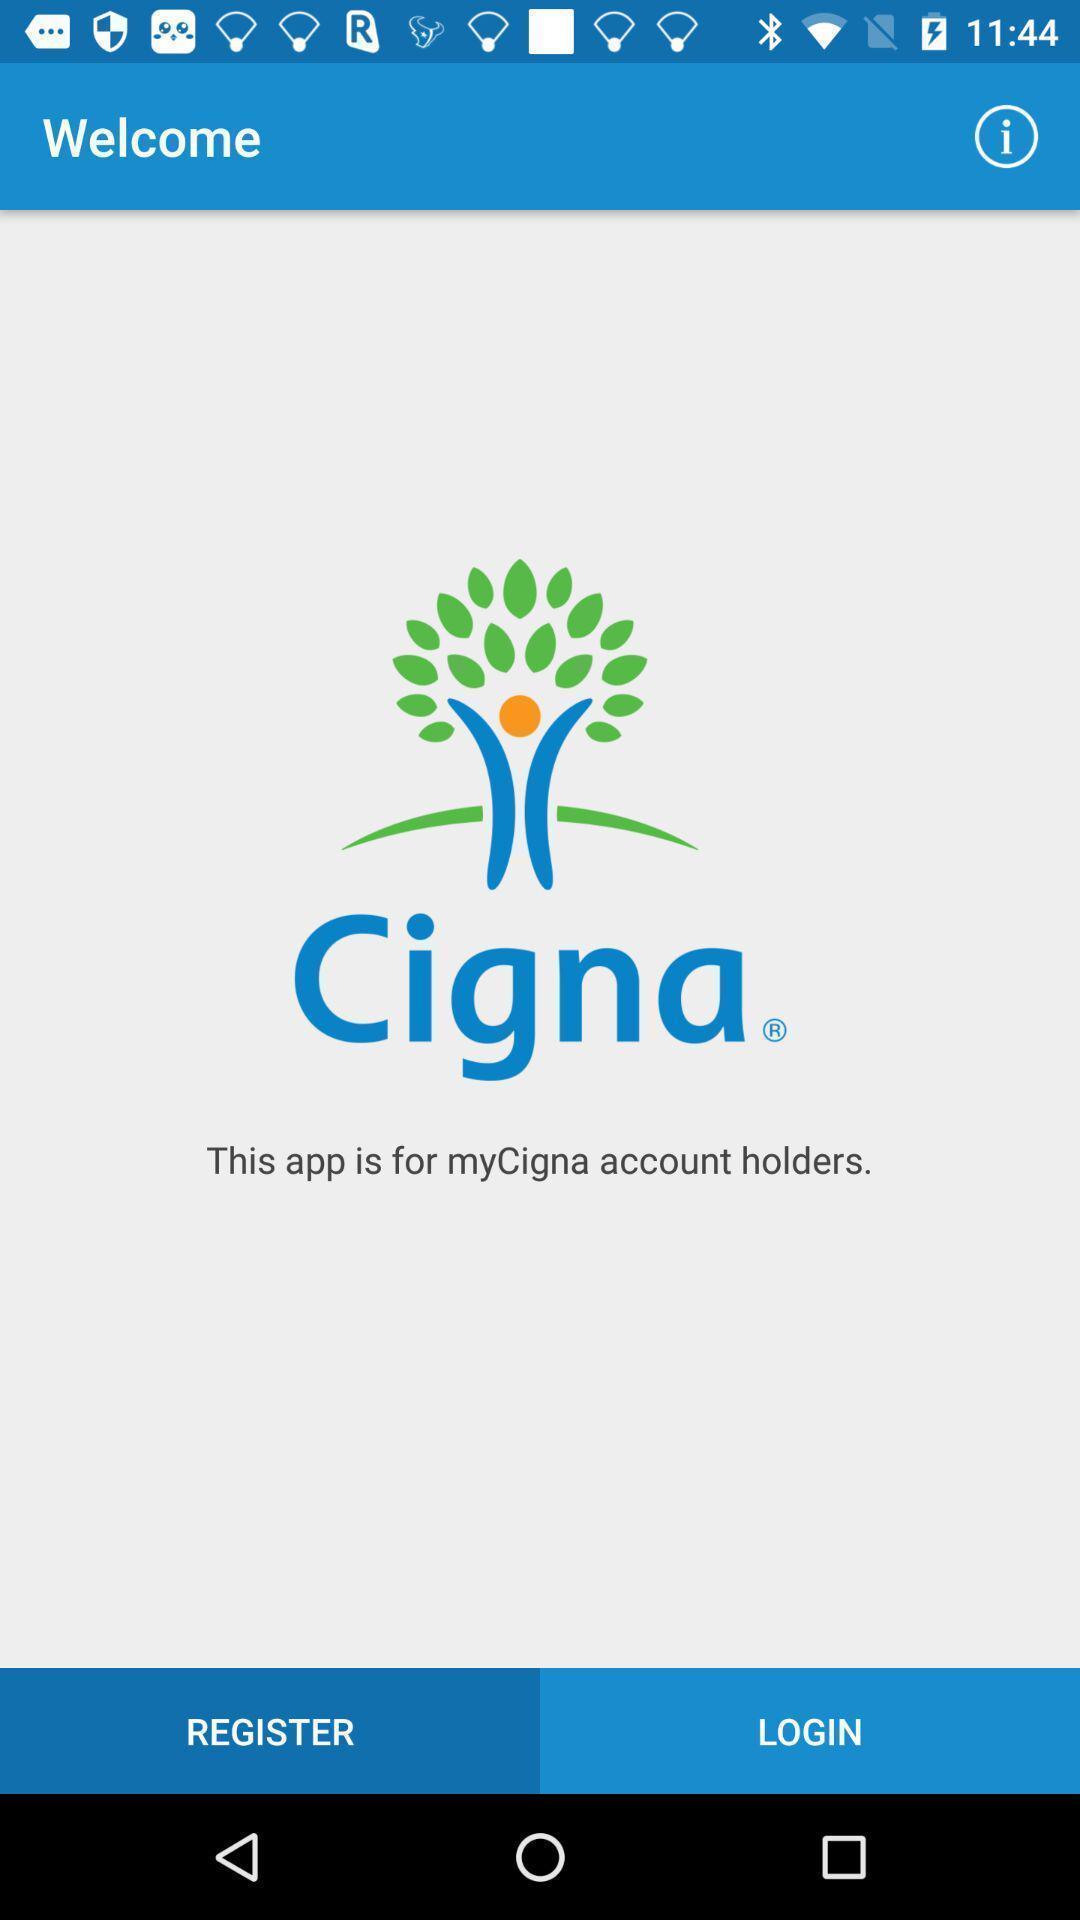Provide a detailed account of this screenshot. Screen shows to register an account. 